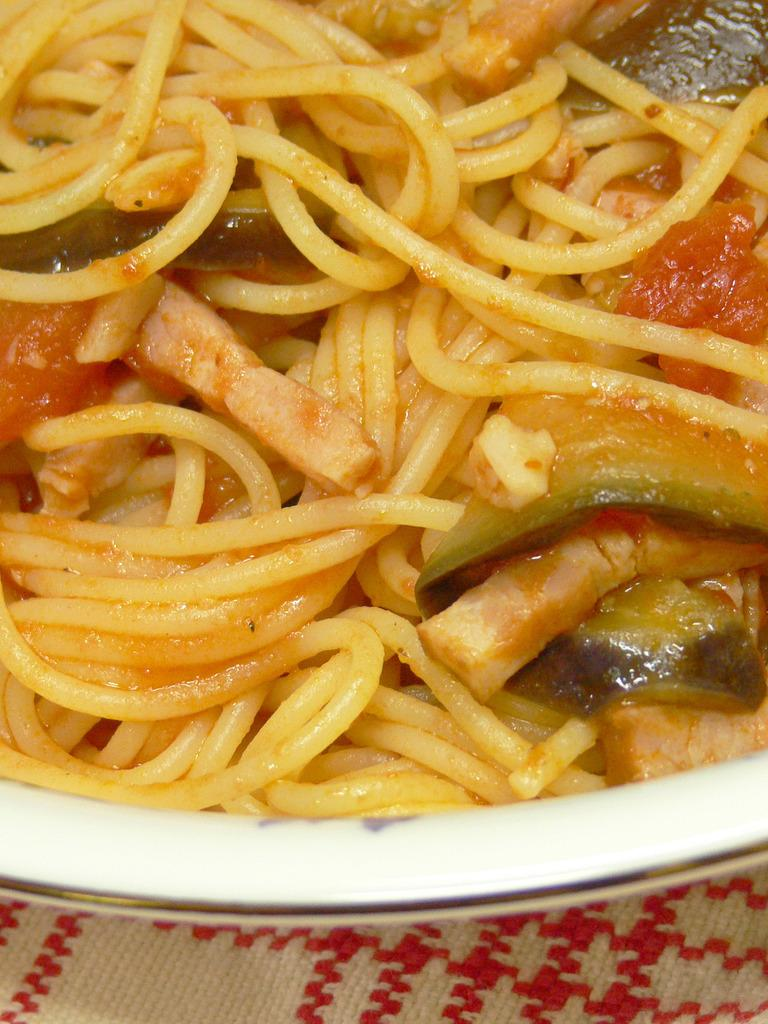What is in the dish that is visible in the image? There is food in a dish in the image. How is the food depicted in the image? The food is truncated towards the top of the image. What else is truncated in the image? There is a cloth truncated towards the bottom of the image. How many oranges are visible in the image? There are no oranges present in the image. What type of van can be seen parked near the dish in the image? There is no van present in the image. 